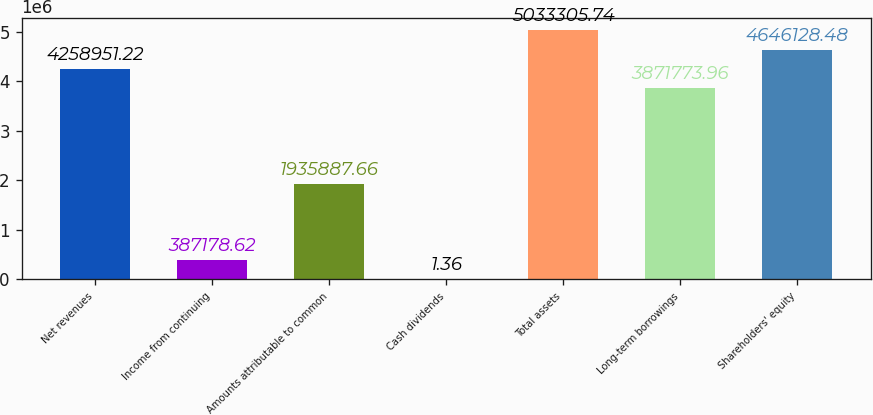<chart> <loc_0><loc_0><loc_500><loc_500><bar_chart><fcel>Net revenues<fcel>Income from continuing<fcel>Amounts attributable to common<fcel>Cash dividends<fcel>Total assets<fcel>Long-term borrowings<fcel>Shareholders' equity<nl><fcel>4.25895e+06<fcel>387179<fcel>1.93589e+06<fcel>1.36<fcel>5.03331e+06<fcel>3.87177e+06<fcel>4.64613e+06<nl></chart> 